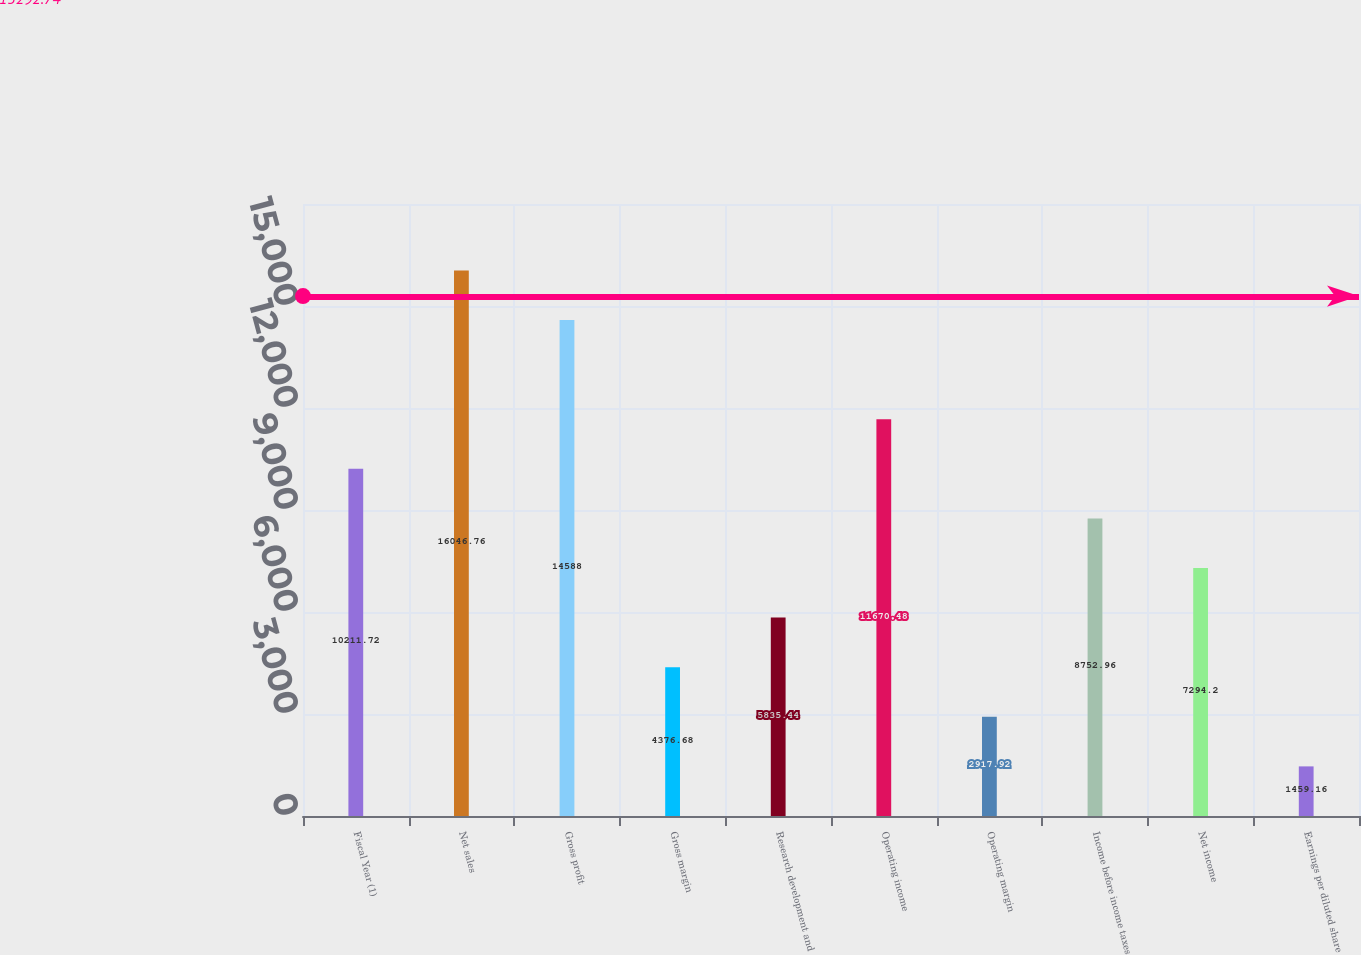Convert chart to OTSL. <chart><loc_0><loc_0><loc_500><loc_500><bar_chart><fcel>Fiscal Year (1)<fcel>Net sales<fcel>Gross profit<fcel>Gross margin<fcel>Research development and<fcel>Operating income<fcel>Operating margin<fcel>Income before income taxes<fcel>Net income<fcel>Earnings per diluted share<nl><fcel>10211.7<fcel>16046.8<fcel>14588<fcel>4376.68<fcel>5835.44<fcel>11670.5<fcel>2917.92<fcel>8752.96<fcel>7294.2<fcel>1459.16<nl></chart> 